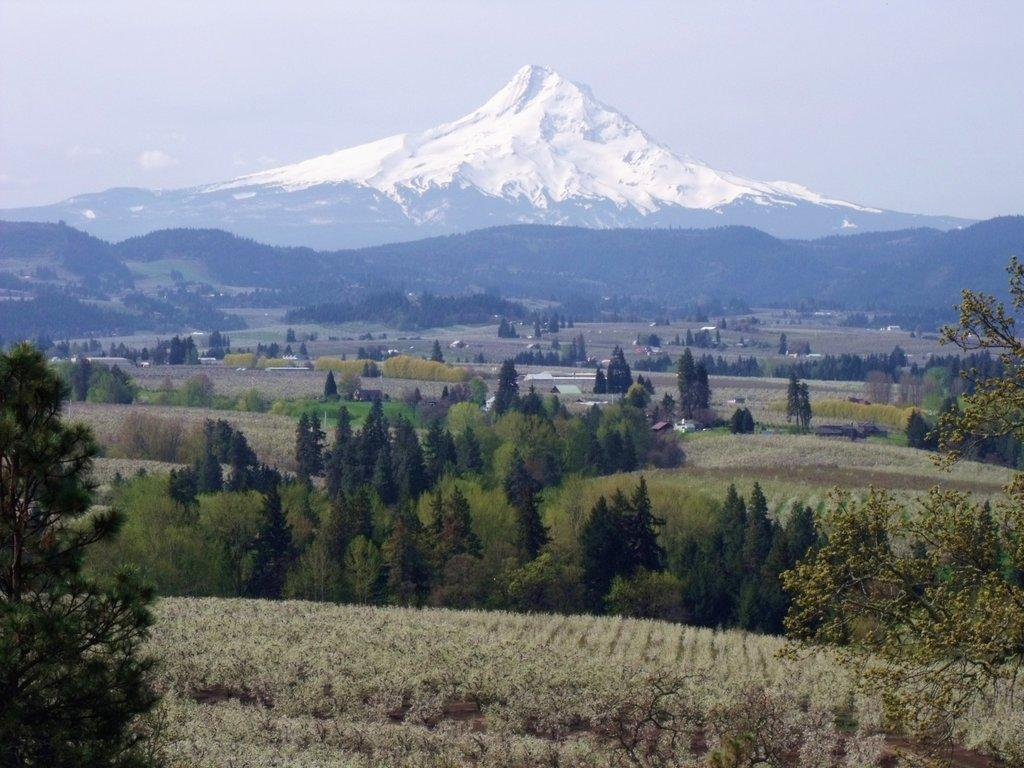What is located in the center of the image? There are trees and plants in the center of the image. What can be seen in the background of the image? There is a snow mountain and sky visible in the background of the image. Can you see your mom standing next to the jellyfish in the image? There is no mom or jellyfish present in the image. 